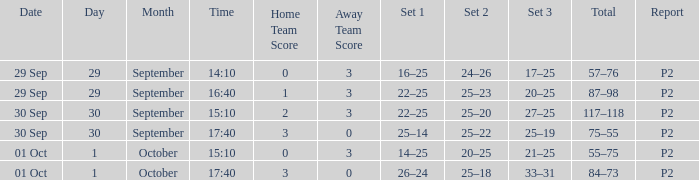For a date of 29 Sep and a time of 16:40, what is the corresponding Set 3? 20–25. 